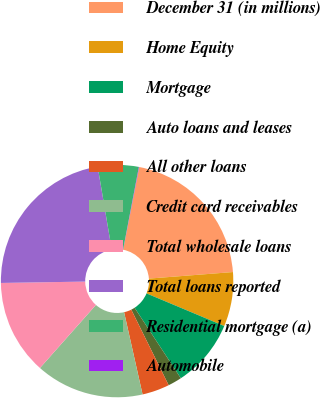Convert chart. <chart><loc_0><loc_0><loc_500><loc_500><pie_chart><fcel>December 31 (in millions)<fcel>Home Equity<fcel>Mortgage<fcel>Auto loans and leases<fcel>All other loans<fcel>Credit card receivables<fcel>Total wholesale loans<fcel>Total loans reported<fcel>Residential mortgage (a)<fcel>Automobile<nl><fcel>20.71%<fcel>7.56%<fcel>9.44%<fcel>1.92%<fcel>3.8%<fcel>15.07%<fcel>13.19%<fcel>22.58%<fcel>5.68%<fcel>0.05%<nl></chart> 